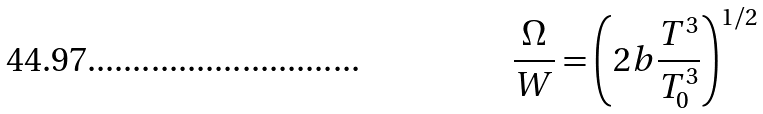Convert formula to latex. <formula><loc_0><loc_0><loc_500><loc_500>\frac { \Omega } { W } = \left ( 2 b \frac { T ^ { 3 } } { T _ { 0 } ^ { 3 } } \right ) ^ { 1 / 2 }</formula> 